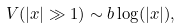Convert formula to latex. <formula><loc_0><loc_0><loc_500><loc_500>V ( | x | \gg 1 ) \sim b \log ( | x | ) ,</formula> 